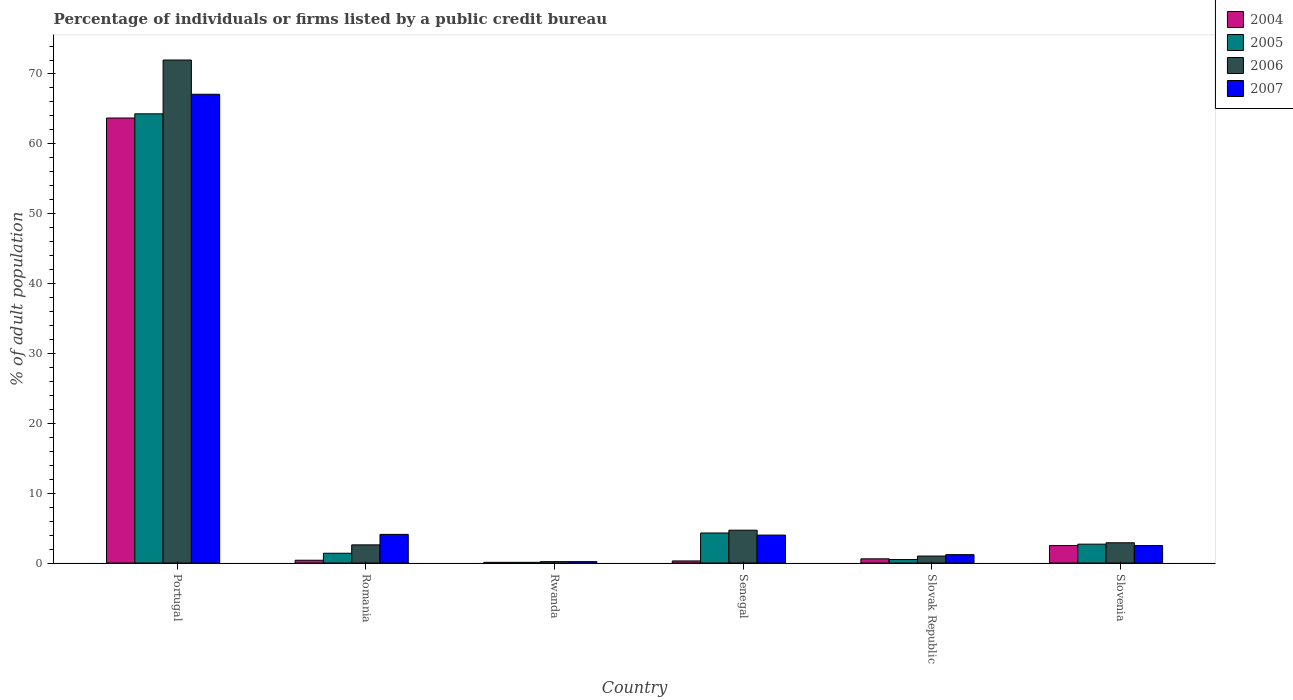How many groups of bars are there?
Give a very brief answer. 6. Are the number of bars on each tick of the X-axis equal?
Give a very brief answer. Yes. How many bars are there on the 3rd tick from the left?
Provide a succinct answer. 4. What is the label of the 4th group of bars from the left?
Your answer should be very brief. Senegal. In how many cases, is the number of bars for a given country not equal to the number of legend labels?
Give a very brief answer. 0. What is the percentage of population listed by a public credit bureau in 2007 in Senegal?
Your answer should be very brief. 4. Across all countries, what is the maximum percentage of population listed by a public credit bureau in 2007?
Your response must be concise. 67.1. In which country was the percentage of population listed by a public credit bureau in 2005 maximum?
Your response must be concise. Portugal. In which country was the percentage of population listed by a public credit bureau in 2004 minimum?
Your answer should be compact. Rwanda. What is the total percentage of population listed by a public credit bureau in 2007 in the graph?
Offer a terse response. 79.1. What is the difference between the percentage of population listed by a public credit bureau in 2006 in Rwanda and that in Senegal?
Your answer should be very brief. -4.5. What is the difference between the percentage of population listed by a public credit bureau in 2004 in Romania and the percentage of population listed by a public credit bureau in 2006 in Portugal?
Make the answer very short. -71.6. What is the average percentage of population listed by a public credit bureau in 2007 per country?
Offer a very short reply. 13.18. What is the difference between the percentage of population listed by a public credit bureau of/in 2004 and percentage of population listed by a public credit bureau of/in 2005 in Portugal?
Provide a short and direct response. -0.6. Is the percentage of population listed by a public credit bureau in 2004 in Romania less than that in Slovak Republic?
Offer a very short reply. Yes. What is the difference between the highest and the second highest percentage of population listed by a public credit bureau in 2005?
Your answer should be compact. 61.6. What is the difference between the highest and the lowest percentage of population listed by a public credit bureau in 2007?
Provide a succinct answer. 66.9. In how many countries, is the percentage of population listed by a public credit bureau in 2007 greater than the average percentage of population listed by a public credit bureau in 2007 taken over all countries?
Offer a very short reply. 1. What does the 2nd bar from the left in Slovak Republic represents?
Make the answer very short. 2005. What does the 2nd bar from the right in Slovak Republic represents?
Provide a short and direct response. 2006. How many bars are there?
Give a very brief answer. 24. Are all the bars in the graph horizontal?
Give a very brief answer. No. What is the difference between two consecutive major ticks on the Y-axis?
Offer a very short reply. 10. Are the values on the major ticks of Y-axis written in scientific E-notation?
Your answer should be compact. No. How many legend labels are there?
Give a very brief answer. 4. How are the legend labels stacked?
Provide a succinct answer. Vertical. What is the title of the graph?
Your response must be concise. Percentage of individuals or firms listed by a public credit bureau. What is the label or title of the Y-axis?
Offer a terse response. % of adult population. What is the % of adult population of 2004 in Portugal?
Make the answer very short. 63.7. What is the % of adult population of 2005 in Portugal?
Ensure brevity in your answer.  64.3. What is the % of adult population of 2007 in Portugal?
Ensure brevity in your answer.  67.1. What is the % of adult population in 2006 in Romania?
Ensure brevity in your answer.  2.6. What is the % of adult population of 2006 in Rwanda?
Your response must be concise. 0.2. What is the % of adult population in 2004 in Senegal?
Make the answer very short. 0.3. What is the % of adult population in 2006 in Senegal?
Make the answer very short. 4.7. What is the % of adult population of 2006 in Slovak Republic?
Ensure brevity in your answer.  1. What is the % of adult population in 2007 in Slovak Republic?
Your response must be concise. 1.2. Across all countries, what is the maximum % of adult population of 2004?
Give a very brief answer. 63.7. Across all countries, what is the maximum % of adult population of 2005?
Ensure brevity in your answer.  64.3. Across all countries, what is the maximum % of adult population in 2007?
Keep it short and to the point. 67.1. Across all countries, what is the minimum % of adult population of 2007?
Offer a very short reply. 0.2. What is the total % of adult population in 2004 in the graph?
Offer a very short reply. 67.6. What is the total % of adult population in 2005 in the graph?
Make the answer very short. 73.3. What is the total % of adult population of 2006 in the graph?
Your response must be concise. 83.4. What is the total % of adult population in 2007 in the graph?
Your response must be concise. 79.1. What is the difference between the % of adult population of 2004 in Portugal and that in Romania?
Your response must be concise. 63.3. What is the difference between the % of adult population of 2005 in Portugal and that in Romania?
Offer a terse response. 62.9. What is the difference between the % of adult population in 2006 in Portugal and that in Romania?
Give a very brief answer. 69.4. What is the difference between the % of adult population of 2004 in Portugal and that in Rwanda?
Your answer should be very brief. 63.6. What is the difference between the % of adult population in 2005 in Portugal and that in Rwanda?
Offer a terse response. 64.2. What is the difference between the % of adult population of 2006 in Portugal and that in Rwanda?
Ensure brevity in your answer.  71.8. What is the difference between the % of adult population of 2007 in Portugal and that in Rwanda?
Make the answer very short. 66.9. What is the difference between the % of adult population of 2004 in Portugal and that in Senegal?
Make the answer very short. 63.4. What is the difference between the % of adult population in 2006 in Portugal and that in Senegal?
Provide a succinct answer. 67.3. What is the difference between the % of adult population of 2007 in Portugal and that in Senegal?
Give a very brief answer. 63.1. What is the difference between the % of adult population of 2004 in Portugal and that in Slovak Republic?
Your response must be concise. 63.1. What is the difference between the % of adult population of 2005 in Portugal and that in Slovak Republic?
Provide a succinct answer. 63.8. What is the difference between the % of adult population of 2006 in Portugal and that in Slovak Republic?
Your answer should be very brief. 71. What is the difference between the % of adult population in 2007 in Portugal and that in Slovak Republic?
Keep it short and to the point. 65.9. What is the difference between the % of adult population of 2004 in Portugal and that in Slovenia?
Keep it short and to the point. 61.2. What is the difference between the % of adult population of 2005 in Portugal and that in Slovenia?
Your answer should be very brief. 61.6. What is the difference between the % of adult population in 2006 in Portugal and that in Slovenia?
Offer a terse response. 69.1. What is the difference between the % of adult population in 2007 in Portugal and that in Slovenia?
Your response must be concise. 64.6. What is the difference between the % of adult population in 2005 in Romania and that in Rwanda?
Your answer should be compact. 1.3. What is the difference between the % of adult population in 2007 in Romania and that in Rwanda?
Provide a short and direct response. 3.9. What is the difference between the % of adult population of 2004 in Romania and that in Senegal?
Make the answer very short. 0.1. What is the difference between the % of adult population in 2005 in Romania and that in Senegal?
Ensure brevity in your answer.  -2.9. What is the difference between the % of adult population of 2005 in Romania and that in Slovak Republic?
Ensure brevity in your answer.  0.9. What is the difference between the % of adult population of 2006 in Romania and that in Slovak Republic?
Keep it short and to the point. 1.6. What is the difference between the % of adult population in 2007 in Romania and that in Slovak Republic?
Your answer should be very brief. 2.9. What is the difference between the % of adult population in 2004 in Romania and that in Slovenia?
Keep it short and to the point. -2.1. What is the difference between the % of adult population of 2006 in Romania and that in Slovenia?
Ensure brevity in your answer.  -0.3. What is the difference between the % of adult population in 2004 in Rwanda and that in Senegal?
Offer a very short reply. -0.2. What is the difference between the % of adult population in 2005 in Rwanda and that in Senegal?
Your response must be concise. -4.2. What is the difference between the % of adult population in 2007 in Rwanda and that in Senegal?
Give a very brief answer. -3.8. What is the difference between the % of adult population of 2004 in Rwanda and that in Slovak Republic?
Keep it short and to the point. -0.5. What is the difference between the % of adult population in 2005 in Rwanda and that in Slovak Republic?
Your response must be concise. -0.4. What is the difference between the % of adult population of 2006 in Rwanda and that in Slovak Republic?
Provide a succinct answer. -0.8. What is the difference between the % of adult population of 2007 in Rwanda and that in Slovak Republic?
Give a very brief answer. -1. What is the difference between the % of adult population in 2004 in Rwanda and that in Slovenia?
Offer a terse response. -2.4. What is the difference between the % of adult population of 2005 in Rwanda and that in Slovenia?
Your response must be concise. -2.6. What is the difference between the % of adult population in 2006 in Rwanda and that in Slovenia?
Provide a succinct answer. -2.7. What is the difference between the % of adult population in 2007 in Rwanda and that in Slovenia?
Make the answer very short. -2.3. What is the difference between the % of adult population in 2004 in Senegal and that in Slovak Republic?
Give a very brief answer. -0.3. What is the difference between the % of adult population of 2005 in Senegal and that in Slovak Republic?
Offer a terse response. 3.8. What is the difference between the % of adult population of 2007 in Senegal and that in Slovak Republic?
Ensure brevity in your answer.  2.8. What is the difference between the % of adult population of 2004 in Senegal and that in Slovenia?
Make the answer very short. -2.2. What is the difference between the % of adult population of 2005 in Senegal and that in Slovenia?
Your answer should be very brief. 1.6. What is the difference between the % of adult population of 2007 in Senegal and that in Slovenia?
Give a very brief answer. 1.5. What is the difference between the % of adult population in 2004 in Slovak Republic and that in Slovenia?
Offer a very short reply. -1.9. What is the difference between the % of adult population in 2005 in Slovak Republic and that in Slovenia?
Offer a terse response. -2.2. What is the difference between the % of adult population of 2004 in Portugal and the % of adult population of 2005 in Romania?
Provide a short and direct response. 62.3. What is the difference between the % of adult population of 2004 in Portugal and the % of adult population of 2006 in Romania?
Ensure brevity in your answer.  61.1. What is the difference between the % of adult population of 2004 in Portugal and the % of adult population of 2007 in Romania?
Your response must be concise. 59.6. What is the difference between the % of adult population of 2005 in Portugal and the % of adult population of 2006 in Romania?
Ensure brevity in your answer.  61.7. What is the difference between the % of adult population of 2005 in Portugal and the % of adult population of 2007 in Romania?
Your answer should be compact. 60.2. What is the difference between the % of adult population of 2006 in Portugal and the % of adult population of 2007 in Romania?
Your answer should be compact. 67.9. What is the difference between the % of adult population in 2004 in Portugal and the % of adult population in 2005 in Rwanda?
Provide a short and direct response. 63.6. What is the difference between the % of adult population in 2004 in Portugal and the % of adult population in 2006 in Rwanda?
Your response must be concise. 63.5. What is the difference between the % of adult population of 2004 in Portugal and the % of adult population of 2007 in Rwanda?
Offer a terse response. 63.5. What is the difference between the % of adult population in 2005 in Portugal and the % of adult population in 2006 in Rwanda?
Your response must be concise. 64.1. What is the difference between the % of adult population in 2005 in Portugal and the % of adult population in 2007 in Rwanda?
Keep it short and to the point. 64.1. What is the difference between the % of adult population of 2006 in Portugal and the % of adult population of 2007 in Rwanda?
Keep it short and to the point. 71.8. What is the difference between the % of adult population of 2004 in Portugal and the % of adult population of 2005 in Senegal?
Keep it short and to the point. 59.4. What is the difference between the % of adult population of 2004 in Portugal and the % of adult population of 2006 in Senegal?
Provide a succinct answer. 59. What is the difference between the % of adult population of 2004 in Portugal and the % of adult population of 2007 in Senegal?
Keep it short and to the point. 59.7. What is the difference between the % of adult population in 2005 in Portugal and the % of adult population in 2006 in Senegal?
Offer a terse response. 59.6. What is the difference between the % of adult population of 2005 in Portugal and the % of adult population of 2007 in Senegal?
Your response must be concise. 60.3. What is the difference between the % of adult population of 2006 in Portugal and the % of adult population of 2007 in Senegal?
Ensure brevity in your answer.  68. What is the difference between the % of adult population of 2004 in Portugal and the % of adult population of 2005 in Slovak Republic?
Keep it short and to the point. 63.2. What is the difference between the % of adult population of 2004 in Portugal and the % of adult population of 2006 in Slovak Republic?
Offer a very short reply. 62.7. What is the difference between the % of adult population of 2004 in Portugal and the % of adult population of 2007 in Slovak Republic?
Your answer should be compact. 62.5. What is the difference between the % of adult population in 2005 in Portugal and the % of adult population in 2006 in Slovak Republic?
Make the answer very short. 63.3. What is the difference between the % of adult population in 2005 in Portugal and the % of adult population in 2007 in Slovak Republic?
Your answer should be compact. 63.1. What is the difference between the % of adult population in 2006 in Portugal and the % of adult population in 2007 in Slovak Republic?
Your response must be concise. 70.8. What is the difference between the % of adult population of 2004 in Portugal and the % of adult population of 2005 in Slovenia?
Your answer should be compact. 61. What is the difference between the % of adult population of 2004 in Portugal and the % of adult population of 2006 in Slovenia?
Provide a short and direct response. 60.8. What is the difference between the % of adult population in 2004 in Portugal and the % of adult population in 2007 in Slovenia?
Make the answer very short. 61.2. What is the difference between the % of adult population of 2005 in Portugal and the % of adult population of 2006 in Slovenia?
Provide a succinct answer. 61.4. What is the difference between the % of adult population of 2005 in Portugal and the % of adult population of 2007 in Slovenia?
Your answer should be compact. 61.8. What is the difference between the % of adult population of 2006 in Portugal and the % of adult population of 2007 in Slovenia?
Offer a very short reply. 69.5. What is the difference between the % of adult population in 2004 in Romania and the % of adult population in 2005 in Rwanda?
Your response must be concise. 0.3. What is the difference between the % of adult population of 2004 in Romania and the % of adult population of 2006 in Rwanda?
Give a very brief answer. 0.2. What is the difference between the % of adult population in 2004 in Romania and the % of adult population in 2005 in Senegal?
Ensure brevity in your answer.  -3.9. What is the difference between the % of adult population of 2004 in Romania and the % of adult population of 2006 in Senegal?
Your answer should be compact. -4.3. What is the difference between the % of adult population of 2004 in Romania and the % of adult population of 2007 in Senegal?
Give a very brief answer. -3.6. What is the difference between the % of adult population of 2005 in Romania and the % of adult population of 2006 in Senegal?
Make the answer very short. -3.3. What is the difference between the % of adult population in 2005 in Romania and the % of adult population in 2007 in Senegal?
Provide a succinct answer. -2.6. What is the difference between the % of adult population of 2004 in Romania and the % of adult population of 2006 in Slovak Republic?
Give a very brief answer. -0.6. What is the difference between the % of adult population in 2004 in Romania and the % of adult population in 2007 in Slovak Republic?
Give a very brief answer. -0.8. What is the difference between the % of adult population in 2005 in Romania and the % of adult population in 2006 in Slovak Republic?
Ensure brevity in your answer.  0.4. What is the difference between the % of adult population in 2005 in Romania and the % of adult population in 2007 in Slovak Republic?
Your answer should be very brief. 0.2. What is the difference between the % of adult population of 2006 in Romania and the % of adult population of 2007 in Slovak Republic?
Your response must be concise. 1.4. What is the difference between the % of adult population in 2004 in Romania and the % of adult population in 2005 in Slovenia?
Keep it short and to the point. -2.3. What is the difference between the % of adult population in 2004 in Romania and the % of adult population in 2006 in Slovenia?
Provide a succinct answer. -2.5. What is the difference between the % of adult population in 2005 in Rwanda and the % of adult population in 2006 in Senegal?
Your response must be concise. -4.6. What is the difference between the % of adult population of 2005 in Rwanda and the % of adult population of 2007 in Senegal?
Give a very brief answer. -3.9. What is the difference between the % of adult population of 2006 in Rwanda and the % of adult population of 2007 in Senegal?
Provide a short and direct response. -3.8. What is the difference between the % of adult population of 2004 in Rwanda and the % of adult population of 2005 in Slovak Republic?
Your response must be concise. -0.4. What is the difference between the % of adult population of 2004 in Rwanda and the % of adult population of 2006 in Slovak Republic?
Keep it short and to the point. -0.9. What is the difference between the % of adult population in 2005 in Rwanda and the % of adult population in 2006 in Slovak Republic?
Your answer should be compact. -0.9. What is the difference between the % of adult population in 2004 in Rwanda and the % of adult population in 2005 in Slovenia?
Provide a succinct answer. -2.6. What is the difference between the % of adult population of 2004 in Rwanda and the % of adult population of 2006 in Slovenia?
Provide a short and direct response. -2.8. What is the difference between the % of adult population of 2004 in Rwanda and the % of adult population of 2007 in Slovenia?
Give a very brief answer. -2.4. What is the difference between the % of adult population in 2005 in Rwanda and the % of adult population in 2006 in Slovenia?
Offer a very short reply. -2.8. What is the difference between the % of adult population of 2004 in Senegal and the % of adult population of 2005 in Slovak Republic?
Give a very brief answer. -0.2. What is the difference between the % of adult population in 2004 in Senegal and the % of adult population in 2006 in Slovak Republic?
Offer a very short reply. -0.7. What is the difference between the % of adult population of 2004 in Senegal and the % of adult population of 2006 in Slovenia?
Keep it short and to the point. -2.6. What is the difference between the % of adult population of 2005 in Senegal and the % of adult population of 2006 in Slovenia?
Give a very brief answer. 1.4. What is the difference between the % of adult population of 2005 in Senegal and the % of adult population of 2007 in Slovenia?
Give a very brief answer. 1.8. What is the difference between the % of adult population in 2004 in Slovak Republic and the % of adult population in 2005 in Slovenia?
Keep it short and to the point. -2.1. What is the difference between the % of adult population of 2004 in Slovak Republic and the % of adult population of 2007 in Slovenia?
Offer a terse response. -1.9. What is the difference between the % of adult population of 2005 in Slovak Republic and the % of adult population of 2006 in Slovenia?
Your answer should be very brief. -2.4. What is the difference between the % of adult population in 2005 in Slovak Republic and the % of adult population in 2007 in Slovenia?
Your answer should be compact. -2. What is the difference between the % of adult population of 2006 in Slovak Republic and the % of adult population of 2007 in Slovenia?
Your answer should be very brief. -1.5. What is the average % of adult population of 2004 per country?
Offer a very short reply. 11.27. What is the average % of adult population of 2005 per country?
Your answer should be compact. 12.22. What is the average % of adult population of 2006 per country?
Provide a short and direct response. 13.9. What is the average % of adult population in 2007 per country?
Provide a short and direct response. 13.18. What is the difference between the % of adult population of 2004 and % of adult population of 2005 in Portugal?
Your answer should be very brief. -0.6. What is the difference between the % of adult population of 2004 and % of adult population of 2006 in Portugal?
Ensure brevity in your answer.  -8.3. What is the difference between the % of adult population in 2004 and % of adult population in 2007 in Portugal?
Provide a succinct answer. -3.4. What is the difference between the % of adult population in 2005 and % of adult population in 2007 in Portugal?
Your answer should be compact. -2.8. What is the difference between the % of adult population of 2006 and % of adult population of 2007 in Portugal?
Your answer should be very brief. 4.9. What is the difference between the % of adult population in 2005 and % of adult population in 2007 in Romania?
Provide a succinct answer. -2.7. What is the difference between the % of adult population of 2004 and % of adult population of 2005 in Rwanda?
Your answer should be compact. 0. What is the difference between the % of adult population in 2004 and % of adult population in 2007 in Rwanda?
Give a very brief answer. -0.1. What is the difference between the % of adult population of 2005 and % of adult population of 2006 in Rwanda?
Your answer should be compact. -0.1. What is the difference between the % of adult population in 2005 and % of adult population in 2007 in Rwanda?
Provide a succinct answer. -0.1. What is the difference between the % of adult population of 2004 and % of adult population of 2005 in Senegal?
Provide a short and direct response. -4. What is the difference between the % of adult population in 2004 and % of adult population in 2006 in Senegal?
Ensure brevity in your answer.  -4.4. What is the difference between the % of adult population in 2004 and % of adult population in 2007 in Senegal?
Provide a succinct answer. -3.7. What is the difference between the % of adult population of 2005 and % of adult population of 2007 in Senegal?
Your response must be concise. 0.3. What is the difference between the % of adult population in 2006 and % of adult population in 2007 in Senegal?
Offer a very short reply. 0.7. What is the difference between the % of adult population of 2004 and % of adult population of 2005 in Slovak Republic?
Offer a very short reply. 0.1. What is the difference between the % of adult population of 2004 and % of adult population of 2006 in Slovak Republic?
Make the answer very short. -0.4. What is the difference between the % of adult population in 2004 and % of adult population in 2007 in Slovak Republic?
Offer a very short reply. -0.6. What is the difference between the % of adult population of 2005 and % of adult population of 2007 in Slovak Republic?
Ensure brevity in your answer.  -0.7. What is the difference between the % of adult population of 2004 and % of adult population of 2006 in Slovenia?
Keep it short and to the point. -0.4. What is the difference between the % of adult population in 2004 and % of adult population in 2007 in Slovenia?
Keep it short and to the point. 0. What is the difference between the % of adult population in 2005 and % of adult population in 2006 in Slovenia?
Keep it short and to the point. -0.2. What is the difference between the % of adult population in 2005 and % of adult population in 2007 in Slovenia?
Offer a terse response. 0.2. What is the ratio of the % of adult population in 2004 in Portugal to that in Romania?
Offer a very short reply. 159.25. What is the ratio of the % of adult population in 2005 in Portugal to that in Romania?
Make the answer very short. 45.93. What is the ratio of the % of adult population in 2006 in Portugal to that in Romania?
Provide a succinct answer. 27.69. What is the ratio of the % of adult population in 2007 in Portugal to that in Romania?
Provide a succinct answer. 16.37. What is the ratio of the % of adult population of 2004 in Portugal to that in Rwanda?
Offer a very short reply. 637. What is the ratio of the % of adult population of 2005 in Portugal to that in Rwanda?
Make the answer very short. 643. What is the ratio of the % of adult population in 2006 in Portugal to that in Rwanda?
Make the answer very short. 360. What is the ratio of the % of adult population of 2007 in Portugal to that in Rwanda?
Provide a short and direct response. 335.5. What is the ratio of the % of adult population of 2004 in Portugal to that in Senegal?
Make the answer very short. 212.33. What is the ratio of the % of adult population in 2005 in Portugal to that in Senegal?
Make the answer very short. 14.95. What is the ratio of the % of adult population of 2006 in Portugal to that in Senegal?
Make the answer very short. 15.32. What is the ratio of the % of adult population in 2007 in Portugal to that in Senegal?
Your answer should be compact. 16.77. What is the ratio of the % of adult population of 2004 in Portugal to that in Slovak Republic?
Provide a succinct answer. 106.17. What is the ratio of the % of adult population in 2005 in Portugal to that in Slovak Republic?
Your answer should be compact. 128.6. What is the ratio of the % of adult population of 2007 in Portugal to that in Slovak Republic?
Your response must be concise. 55.92. What is the ratio of the % of adult population in 2004 in Portugal to that in Slovenia?
Offer a very short reply. 25.48. What is the ratio of the % of adult population of 2005 in Portugal to that in Slovenia?
Give a very brief answer. 23.81. What is the ratio of the % of adult population in 2006 in Portugal to that in Slovenia?
Give a very brief answer. 24.83. What is the ratio of the % of adult population in 2007 in Portugal to that in Slovenia?
Provide a short and direct response. 26.84. What is the ratio of the % of adult population in 2004 in Romania to that in Rwanda?
Give a very brief answer. 4. What is the ratio of the % of adult population of 2005 in Romania to that in Rwanda?
Give a very brief answer. 14. What is the ratio of the % of adult population of 2005 in Romania to that in Senegal?
Give a very brief answer. 0.33. What is the ratio of the % of adult population of 2006 in Romania to that in Senegal?
Give a very brief answer. 0.55. What is the ratio of the % of adult population of 2006 in Romania to that in Slovak Republic?
Ensure brevity in your answer.  2.6. What is the ratio of the % of adult population of 2007 in Romania to that in Slovak Republic?
Offer a very short reply. 3.42. What is the ratio of the % of adult population in 2004 in Romania to that in Slovenia?
Offer a very short reply. 0.16. What is the ratio of the % of adult population in 2005 in Romania to that in Slovenia?
Provide a succinct answer. 0.52. What is the ratio of the % of adult population in 2006 in Romania to that in Slovenia?
Ensure brevity in your answer.  0.9. What is the ratio of the % of adult population in 2007 in Romania to that in Slovenia?
Give a very brief answer. 1.64. What is the ratio of the % of adult population of 2004 in Rwanda to that in Senegal?
Offer a very short reply. 0.33. What is the ratio of the % of adult population in 2005 in Rwanda to that in Senegal?
Your answer should be compact. 0.02. What is the ratio of the % of adult population in 2006 in Rwanda to that in Senegal?
Your answer should be very brief. 0.04. What is the ratio of the % of adult population of 2004 in Rwanda to that in Slovak Republic?
Your response must be concise. 0.17. What is the ratio of the % of adult population in 2005 in Rwanda to that in Slovak Republic?
Give a very brief answer. 0.2. What is the ratio of the % of adult population of 2007 in Rwanda to that in Slovak Republic?
Ensure brevity in your answer.  0.17. What is the ratio of the % of adult population in 2004 in Rwanda to that in Slovenia?
Give a very brief answer. 0.04. What is the ratio of the % of adult population in 2005 in Rwanda to that in Slovenia?
Provide a succinct answer. 0.04. What is the ratio of the % of adult population of 2006 in Rwanda to that in Slovenia?
Your answer should be very brief. 0.07. What is the ratio of the % of adult population in 2005 in Senegal to that in Slovak Republic?
Your answer should be compact. 8.6. What is the ratio of the % of adult population in 2007 in Senegal to that in Slovak Republic?
Provide a succinct answer. 3.33. What is the ratio of the % of adult population in 2004 in Senegal to that in Slovenia?
Offer a very short reply. 0.12. What is the ratio of the % of adult population of 2005 in Senegal to that in Slovenia?
Provide a succinct answer. 1.59. What is the ratio of the % of adult population of 2006 in Senegal to that in Slovenia?
Ensure brevity in your answer.  1.62. What is the ratio of the % of adult population of 2007 in Senegal to that in Slovenia?
Offer a terse response. 1.6. What is the ratio of the % of adult population in 2004 in Slovak Republic to that in Slovenia?
Make the answer very short. 0.24. What is the ratio of the % of adult population in 2005 in Slovak Republic to that in Slovenia?
Your answer should be compact. 0.19. What is the ratio of the % of adult population in 2006 in Slovak Republic to that in Slovenia?
Your response must be concise. 0.34. What is the ratio of the % of adult population in 2007 in Slovak Republic to that in Slovenia?
Your answer should be compact. 0.48. What is the difference between the highest and the second highest % of adult population of 2004?
Your answer should be very brief. 61.2. What is the difference between the highest and the second highest % of adult population in 2006?
Ensure brevity in your answer.  67.3. What is the difference between the highest and the lowest % of adult population of 2004?
Give a very brief answer. 63.6. What is the difference between the highest and the lowest % of adult population of 2005?
Offer a terse response. 64.2. What is the difference between the highest and the lowest % of adult population in 2006?
Offer a terse response. 71.8. What is the difference between the highest and the lowest % of adult population of 2007?
Your response must be concise. 66.9. 